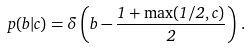Convert formula to latex. <formula><loc_0><loc_0><loc_500><loc_500>p ( b | c ) = \delta \left ( b - \frac { 1 + \max ( 1 / 2 , c ) } { 2 } \right ) \, .</formula> 